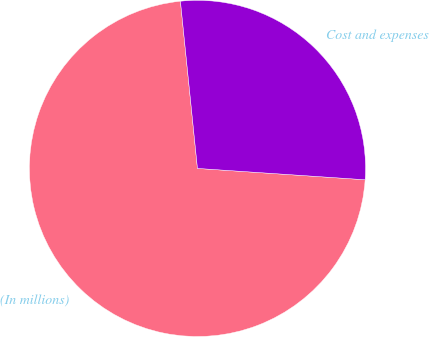Convert chart to OTSL. <chart><loc_0><loc_0><loc_500><loc_500><pie_chart><fcel>(In millions)<fcel>Cost and expenses<nl><fcel>72.31%<fcel>27.69%<nl></chart> 